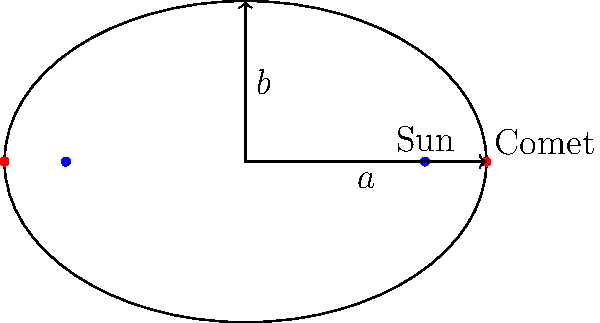In the elliptical orbit of a comet around the Sun, as shown in the diagram, the Sun is located at one of the foci. If the semi-major axis (a) is 3 AU and the semi-minor axis (b) is 2 AU, what is the eccentricity (e) of the orbit? Express your answer in terms of the ratio of two whole numbers. To find the eccentricity of the comet's orbit, we can follow these steps:

1. Recall the formula for eccentricity of an ellipse:
   $$ e = \frac{c}{a} $$
   where $c$ is the distance from the center to a focus, and $a$ is the semi-major axis.

2. We're given $a = 3$ AU and $b = 2$ AU.

3. To find $c$, we can use the Pythagorean theorem for ellipses:
   $$ a^2 = b^2 + c^2 $$

4. Substitute the known values:
   $$ 3^2 = 2^2 + c^2 $$
   $$ 9 = 4 + c^2 $$

5. Solve for $c$:
   $$ c^2 = 9 - 4 = 5 $$
   $$ c = \sqrt{5} $$

6. Now we can calculate the eccentricity:
   $$ e = \frac{c}{a} = \frac{\sqrt{5}}{3} $$

7. To express this as a ratio of whole numbers, we can rationalize the denominator:
   $$ e = \frac{\sqrt{5}}{3} \cdot \frac{\sqrt{5}}{\sqrt{5}} = \frac{5}{3\sqrt{5}} $$

8. This simplifies to:
   $$ e = \frac{\sqrt{5}}{3} $$

Therefore, the eccentricity of the comet's orbit is $\frac{\sqrt{5}}{3}$.
Answer: $\frac{\sqrt{5}}{3}$ 